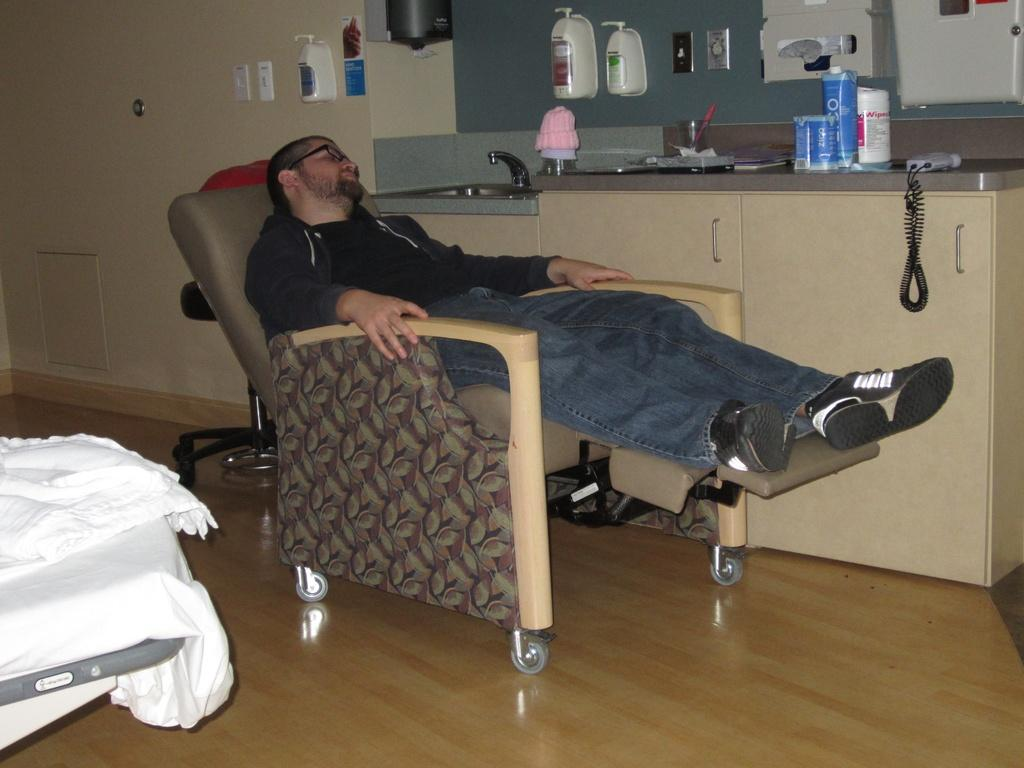What type of structure is present in the image? There is a wall in the image. What piece of furniture is in the room? There is a bed in the image. What is the man in the image doing? The man is sitting on a chair in the image. What communication device is visible in the image? There is a telephone in the image. What is used for washing or cleaning in the image? There is a sink in the image. What type of dress is the man wearing in the image? The man is not wearing a dress in the image; he is sitting on a chair. How many trucks can be seen in the image? There are no trucks present in the image. 